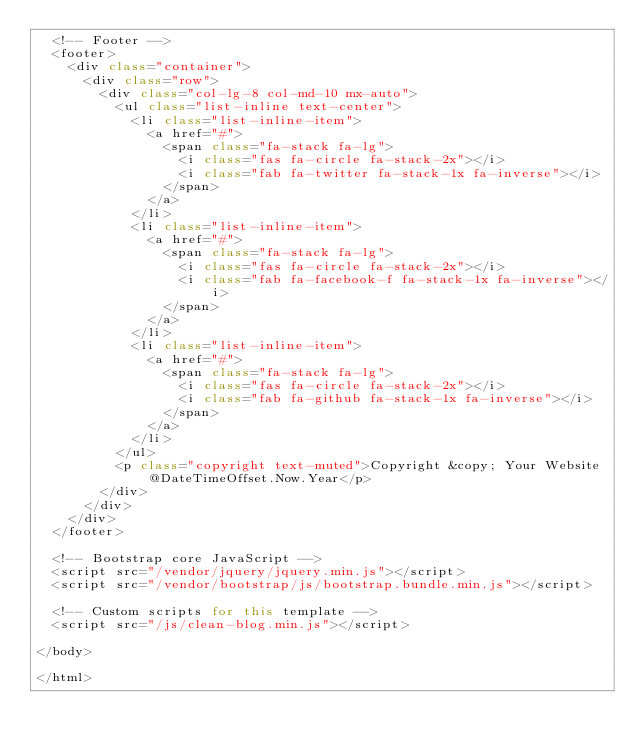Convert code to text. <code><loc_0><loc_0><loc_500><loc_500><_C#_>  <!-- Footer -->
  <footer>
    <div class="container">
      <div class="row">
        <div class="col-lg-8 col-md-10 mx-auto">
          <ul class="list-inline text-center">
            <li class="list-inline-item">
              <a href="#">
                <span class="fa-stack fa-lg">
                  <i class="fas fa-circle fa-stack-2x"></i>
                  <i class="fab fa-twitter fa-stack-1x fa-inverse"></i>
                </span>
              </a>
            </li>
            <li class="list-inline-item">
              <a href="#">
                <span class="fa-stack fa-lg">
                  <i class="fas fa-circle fa-stack-2x"></i>
                  <i class="fab fa-facebook-f fa-stack-1x fa-inverse"></i>
                </span>
              </a>
            </li>
            <li class="list-inline-item">
              <a href="#">
                <span class="fa-stack fa-lg">
                  <i class="fas fa-circle fa-stack-2x"></i>
                  <i class="fab fa-github fa-stack-1x fa-inverse"></i>
                </span>
              </a>
            </li>
          </ul>
          <p class="copyright text-muted">Copyright &copy; Your Website @DateTimeOffset.Now.Year</p>
        </div>
      </div>
    </div>
  </footer>

  <!-- Bootstrap core JavaScript -->
  <script src="/vendor/jquery/jquery.min.js"></script>
  <script src="/vendor/bootstrap/js/bootstrap.bundle.min.js"></script>

  <!-- Custom scripts for this template -->
  <script src="/js/clean-blog.min.js"></script>

</body>

</html>
</code> 